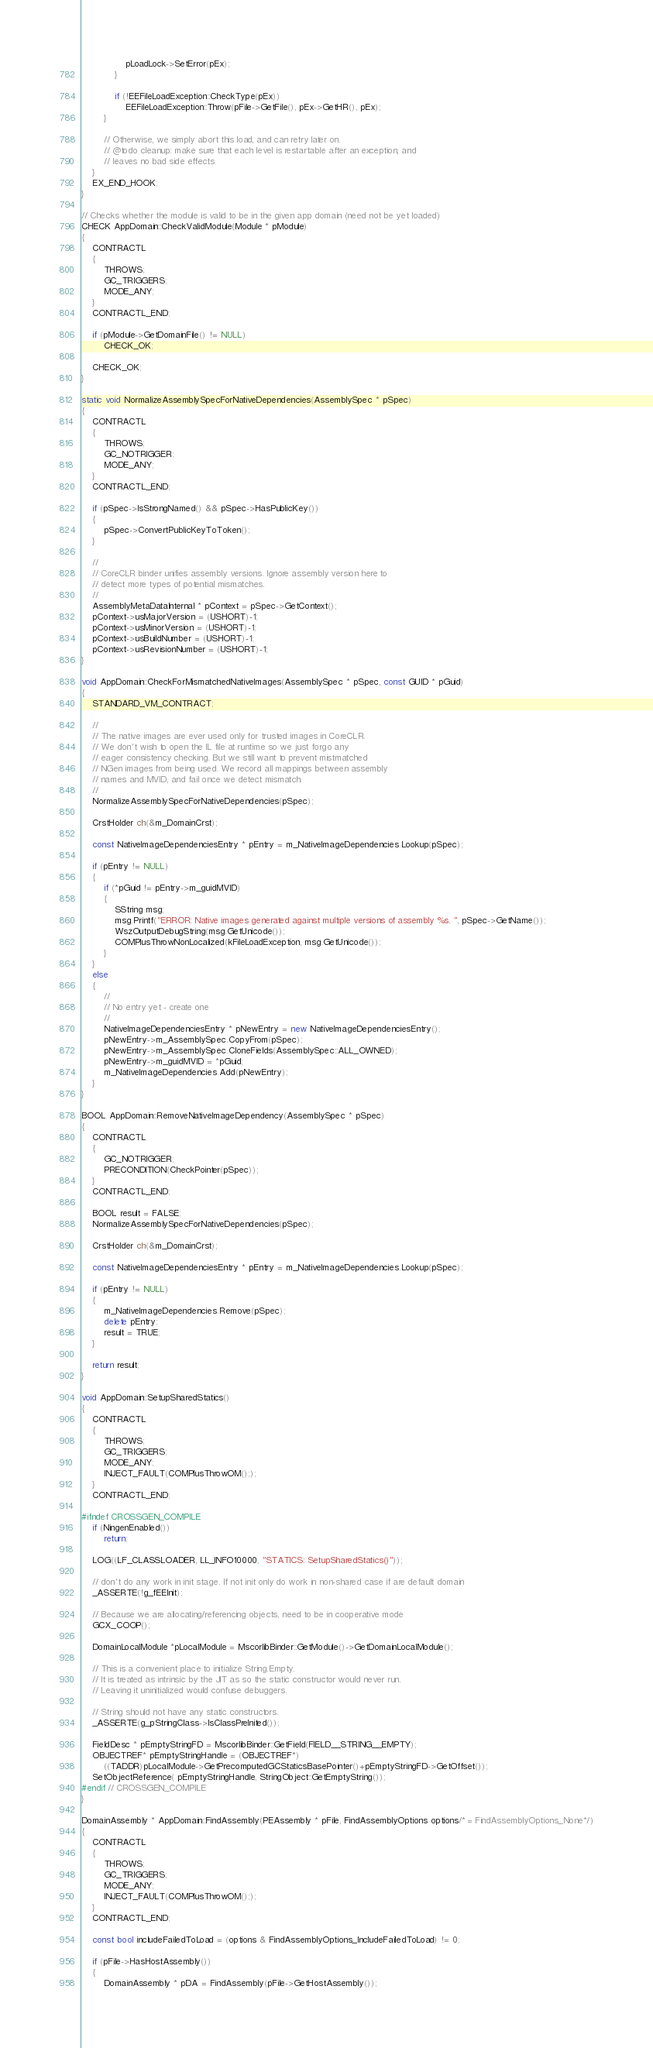Convert code to text. <code><loc_0><loc_0><loc_500><loc_500><_C++_>                pLoadLock->SetError(pEx);
            }

            if (!EEFileLoadException::CheckType(pEx))
                EEFileLoadException::Throw(pFile->GetFile(), pEx->GetHR(), pEx);
        }

        // Otherwise, we simply abort this load, and can retry later on.
        // @todo cleanup: make sure that each level is restartable after an exception, and
        // leaves no bad side effects
    }
    EX_END_HOOK;
}

// Checks whether the module is valid to be in the given app domain (need not be yet loaded)
CHECK AppDomain::CheckValidModule(Module * pModule)
{
    CONTRACTL
    {
        THROWS;
        GC_TRIGGERS;
        MODE_ANY;
    }
    CONTRACTL_END;

    if (pModule->GetDomainFile() != NULL)
        CHECK_OK;

    CHECK_OK;
}

static void NormalizeAssemblySpecForNativeDependencies(AssemblySpec * pSpec)
{
    CONTRACTL
    {
        THROWS;
        GC_NOTRIGGER;
        MODE_ANY;
    }
    CONTRACTL_END;

    if (pSpec->IsStrongNamed() && pSpec->HasPublicKey())
    {
        pSpec->ConvertPublicKeyToToken();
    }

    //
    // CoreCLR binder unifies assembly versions. Ignore assembly version here to
    // detect more types of potential mismatches.
    //
    AssemblyMetaDataInternal * pContext = pSpec->GetContext();
    pContext->usMajorVersion = (USHORT)-1;
    pContext->usMinorVersion = (USHORT)-1;
    pContext->usBuildNumber = (USHORT)-1;
    pContext->usRevisionNumber = (USHORT)-1;
}

void AppDomain::CheckForMismatchedNativeImages(AssemblySpec * pSpec, const GUID * pGuid)
{
    STANDARD_VM_CONTRACT;

    //
    // The native images are ever used only for trusted images in CoreCLR.
    // We don't wish to open the IL file at runtime so we just forgo any
    // eager consistency checking. But we still want to prevent mistmatched
    // NGen images from being used. We record all mappings between assembly
    // names and MVID, and fail once we detect mismatch.
    //
    NormalizeAssemblySpecForNativeDependencies(pSpec);

    CrstHolder ch(&m_DomainCrst);

    const NativeImageDependenciesEntry * pEntry = m_NativeImageDependencies.Lookup(pSpec);

    if (pEntry != NULL)
    {
        if (*pGuid != pEntry->m_guidMVID)
        {
            SString msg;
            msg.Printf("ERROR: Native images generated against multiple versions of assembly %s. ", pSpec->GetName());
            WszOutputDebugString(msg.GetUnicode());
            COMPlusThrowNonLocalized(kFileLoadException, msg.GetUnicode());
        }
    }
    else
    {
        //
        // No entry yet - create one
        //
        NativeImageDependenciesEntry * pNewEntry = new NativeImageDependenciesEntry();
        pNewEntry->m_AssemblySpec.CopyFrom(pSpec);
        pNewEntry->m_AssemblySpec.CloneFields(AssemblySpec::ALL_OWNED);
        pNewEntry->m_guidMVID = *pGuid;
        m_NativeImageDependencies.Add(pNewEntry);
    }
}

BOOL AppDomain::RemoveNativeImageDependency(AssemblySpec * pSpec)
{
    CONTRACTL
    {
        GC_NOTRIGGER;
        PRECONDITION(CheckPointer(pSpec));
    }
    CONTRACTL_END;

    BOOL result = FALSE;
    NormalizeAssemblySpecForNativeDependencies(pSpec);

    CrstHolder ch(&m_DomainCrst);

    const NativeImageDependenciesEntry * pEntry = m_NativeImageDependencies.Lookup(pSpec);

    if (pEntry != NULL)
    {
        m_NativeImageDependencies.Remove(pSpec);
        delete pEntry;
        result = TRUE;
    }

    return result;
}

void AppDomain::SetupSharedStatics()
{
    CONTRACTL
    {
        THROWS;
        GC_TRIGGERS;
        MODE_ANY;
        INJECT_FAULT(COMPlusThrowOM(););
    }
    CONTRACTL_END;

#ifndef CROSSGEN_COMPILE
    if (NingenEnabled())
        return;

    LOG((LF_CLASSLOADER, LL_INFO10000, "STATICS: SetupSharedStatics()"));

    // don't do any work in init stage. If not init only do work in non-shared case if are default domain
    _ASSERTE(!g_fEEInit);

    // Because we are allocating/referencing objects, need to be in cooperative mode
    GCX_COOP();

    DomainLocalModule *pLocalModule = MscorlibBinder::GetModule()->GetDomainLocalModule();

    // This is a convenient place to initialize String.Empty.
    // It is treated as intrinsic by the JIT as so the static constructor would never run.
    // Leaving it uninitialized would confuse debuggers.

    // String should not have any static constructors.
    _ASSERTE(g_pStringClass->IsClassPreInited());

    FieldDesc * pEmptyStringFD = MscorlibBinder::GetField(FIELD__STRING__EMPTY);
    OBJECTREF* pEmptyStringHandle = (OBJECTREF*)
        ((TADDR)pLocalModule->GetPrecomputedGCStaticsBasePointer()+pEmptyStringFD->GetOffset());
    SetObjectReference( pEmptyStringHandle, StringObject::GetEmptyString());
#endif // CROSSGEN_COMPILE
}

DomainAssembly * AppDomain::FindAssembly(PEAssembly * pFile, FindAssemblyOptions options/* = FindAssemblyOptions_None*/)
{
    CONTRACTL
    {
        THROWS;
        GC_TRIGGERS;
        MODE_ANY;
        INJECT_FAULT(COMPlusThrowOM(););
    }
    CONTRACTL_END;

    const bool includeFailedToLoad = (options & FindAssemblyOptions_IncludeFailedToLoad) != 0;

    if (pFile->HasHostAssembly())
    {
        DomainAssembly * pDA = FindAssembly(pFile->GetHostAssembly());</code> 